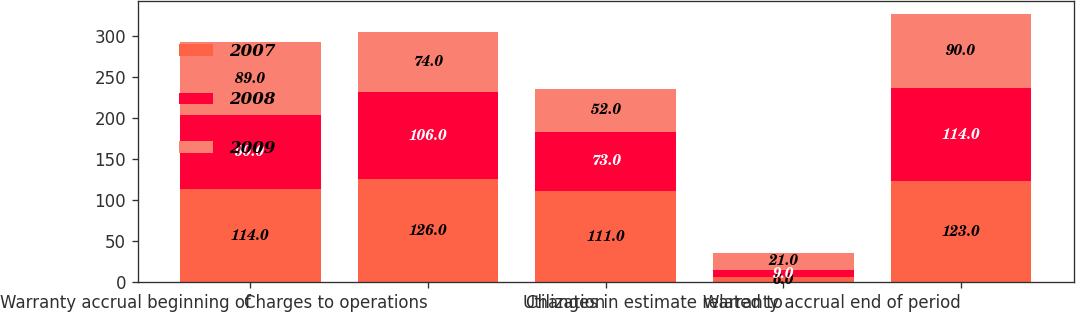Convert chart. <chart><loc_0><loc_0><loc_500><loc_500><stacked_bar_chart><ecel><fcel>Warranty accrual beginning of<fcel>Charges to operations<fcel>Utilization<fcel>Changes in estimate related to<fcel>Warranty accrual end of period<nl><fcel>2007<fcel>114<fcel>126<fcel>111<fcel>6<fcel>123<nl><fcel>2008<fcel>90<fcel>106<fcel>73<fcel>9<fcel>114<nl><fcel>2009<fcel>89<fcel>74<fcel>52<fcel>21<fcel>90<nl></chart> 